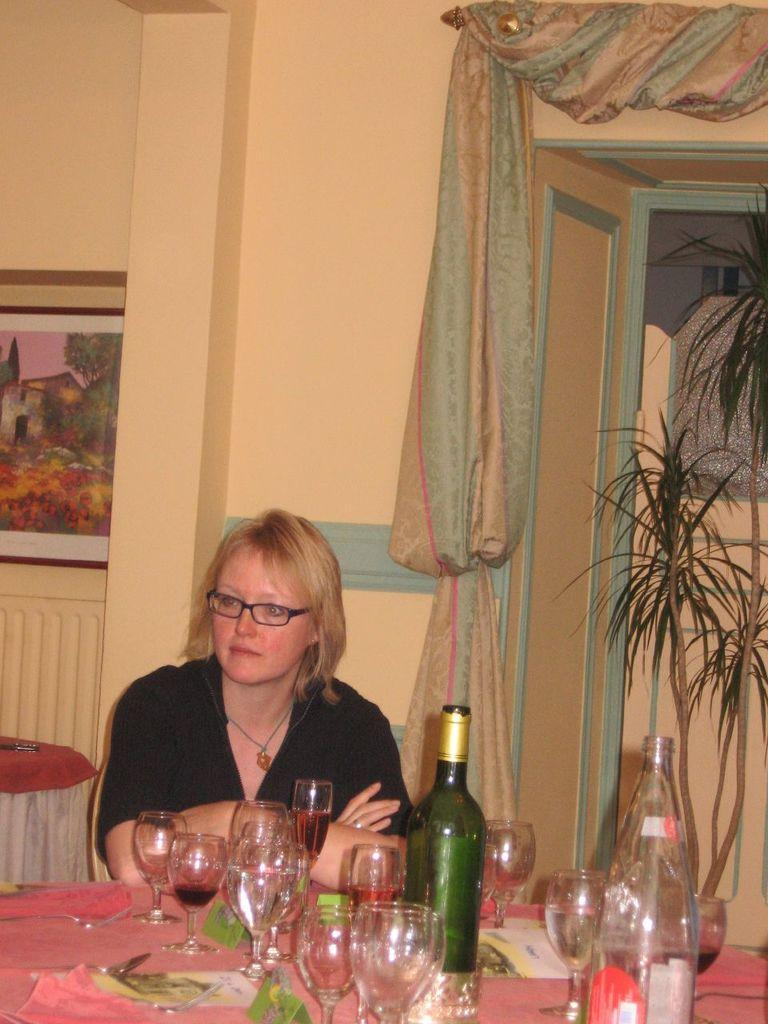Who is the main subject in the image? There is a lady in the image. What is the lady doing in the image? The lady is sitting on chairs. Where are the chairs located in relation to the table? The chairs are in front of a table. What items can be seen on the table? There are glasses and bottles on the table. What is the purpose of the curtain in the image? The curtain is visible in the image, but its purpose is not explicitly stated. Can you see the lady attempting to fall into the sea in the image? There is no sea present in the image, and the lady is sitting on chairs, not attempting to fall into any body of water. 